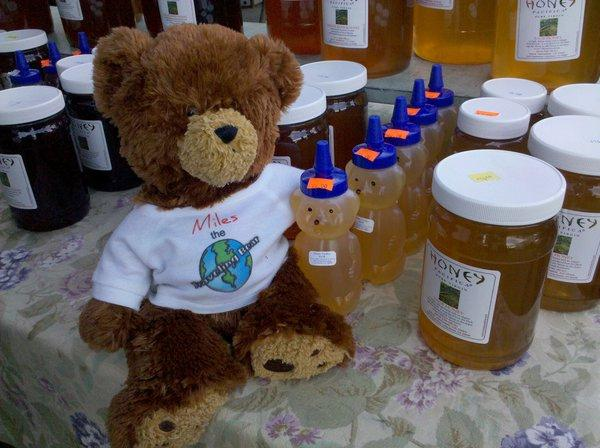What color are the tags on top of the honey dispensers? orange 